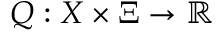Convert formula to latex. <formula><loc_0><loc_0><loc_500><loc_500>Q \colon X \times \Xi \rightarrow \mathbb { R }</formula> 